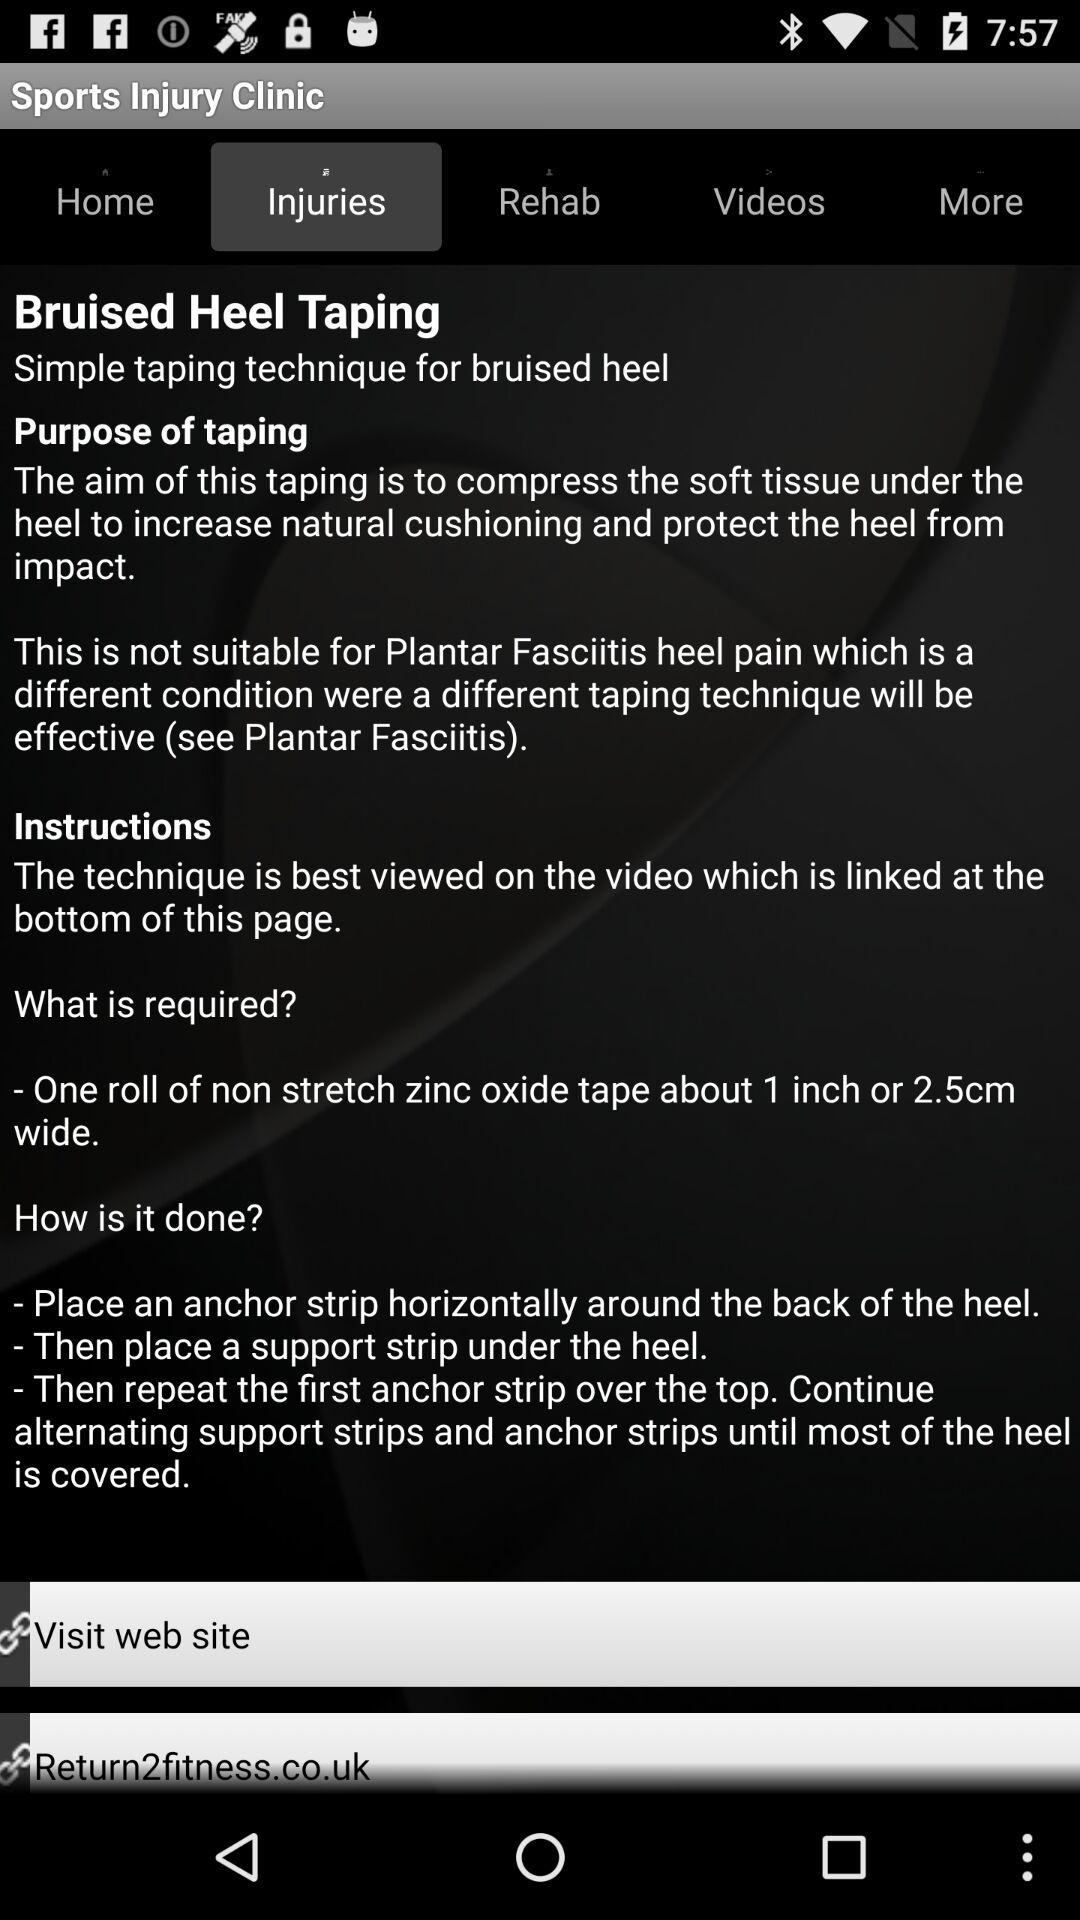What is the instruction for taping? The instruction for taping is "The technique is best viewed on the video which is linked at the bottom of this page". 